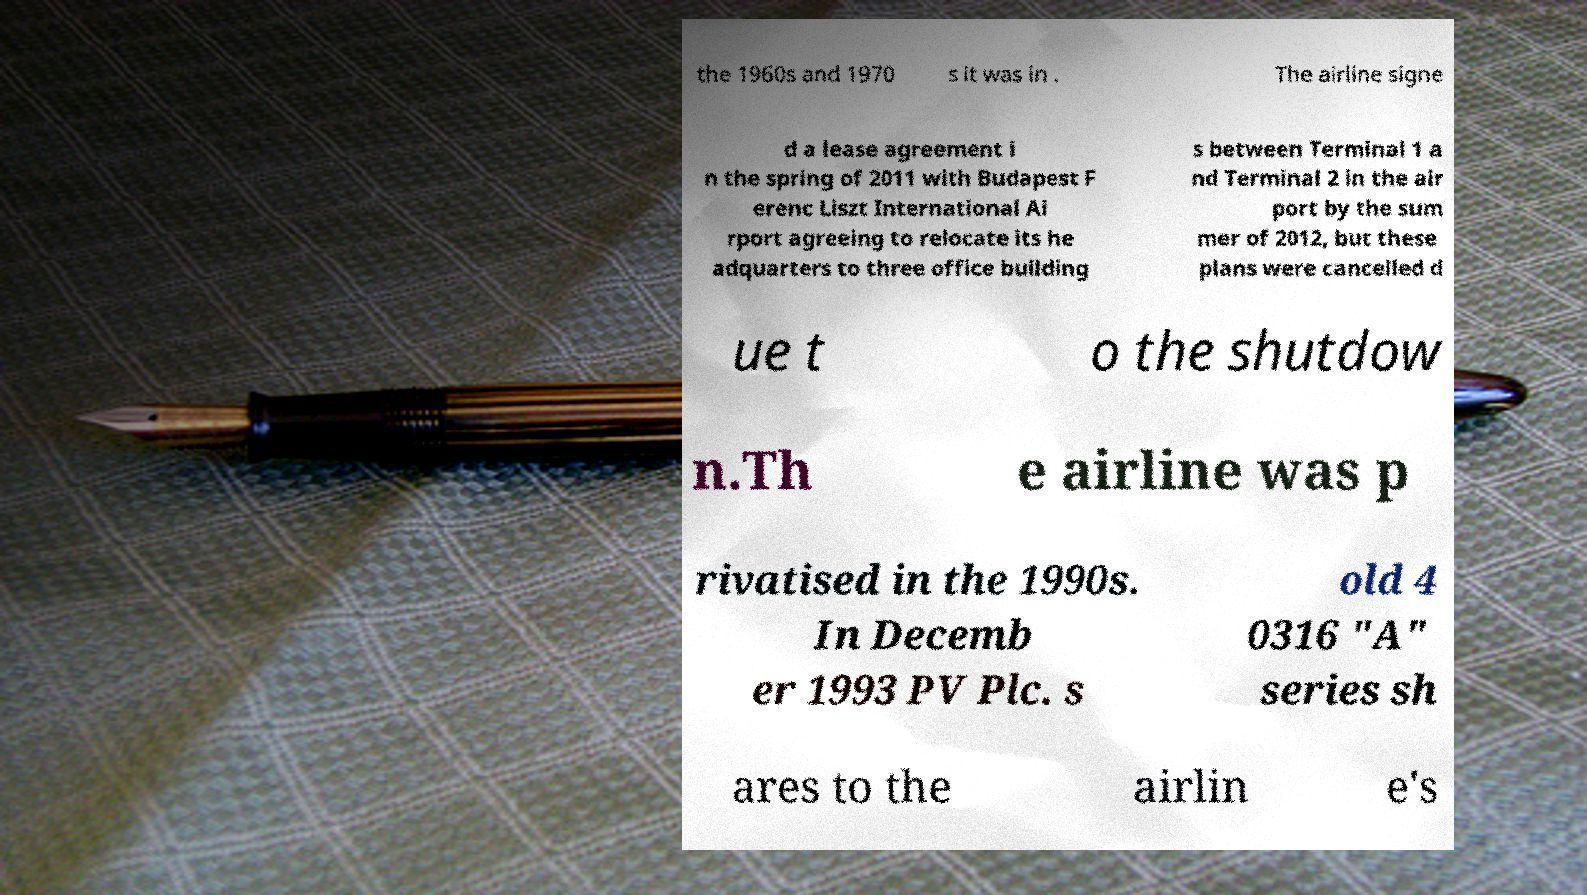There's text embedded in this image that I need extracted. Can you transcribe it verbatim? the 1960s and 1970 s it was in . The airline signe d a lease agreement i n the spring of 2011 with Budapest F erenc Liszt International Ai rport agreeing to relocate its he adquarters to three office building s between Terminal 1 a nd Terminal 2 in the air port by the sum mer of 2012, but these plans were cancelled d ue t o the shutdow n.Th e airline was p rivatised in the 1990s. In Decemb er 1993 PV Plc. s old 4 0316 "A" series sh ares to the airlin e's 